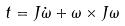Convert formula to latex. <formula><loc_0><loc_0><loc_500><loc_500>t = J \dot { \omega } + \omega \times J \omega</formula> 